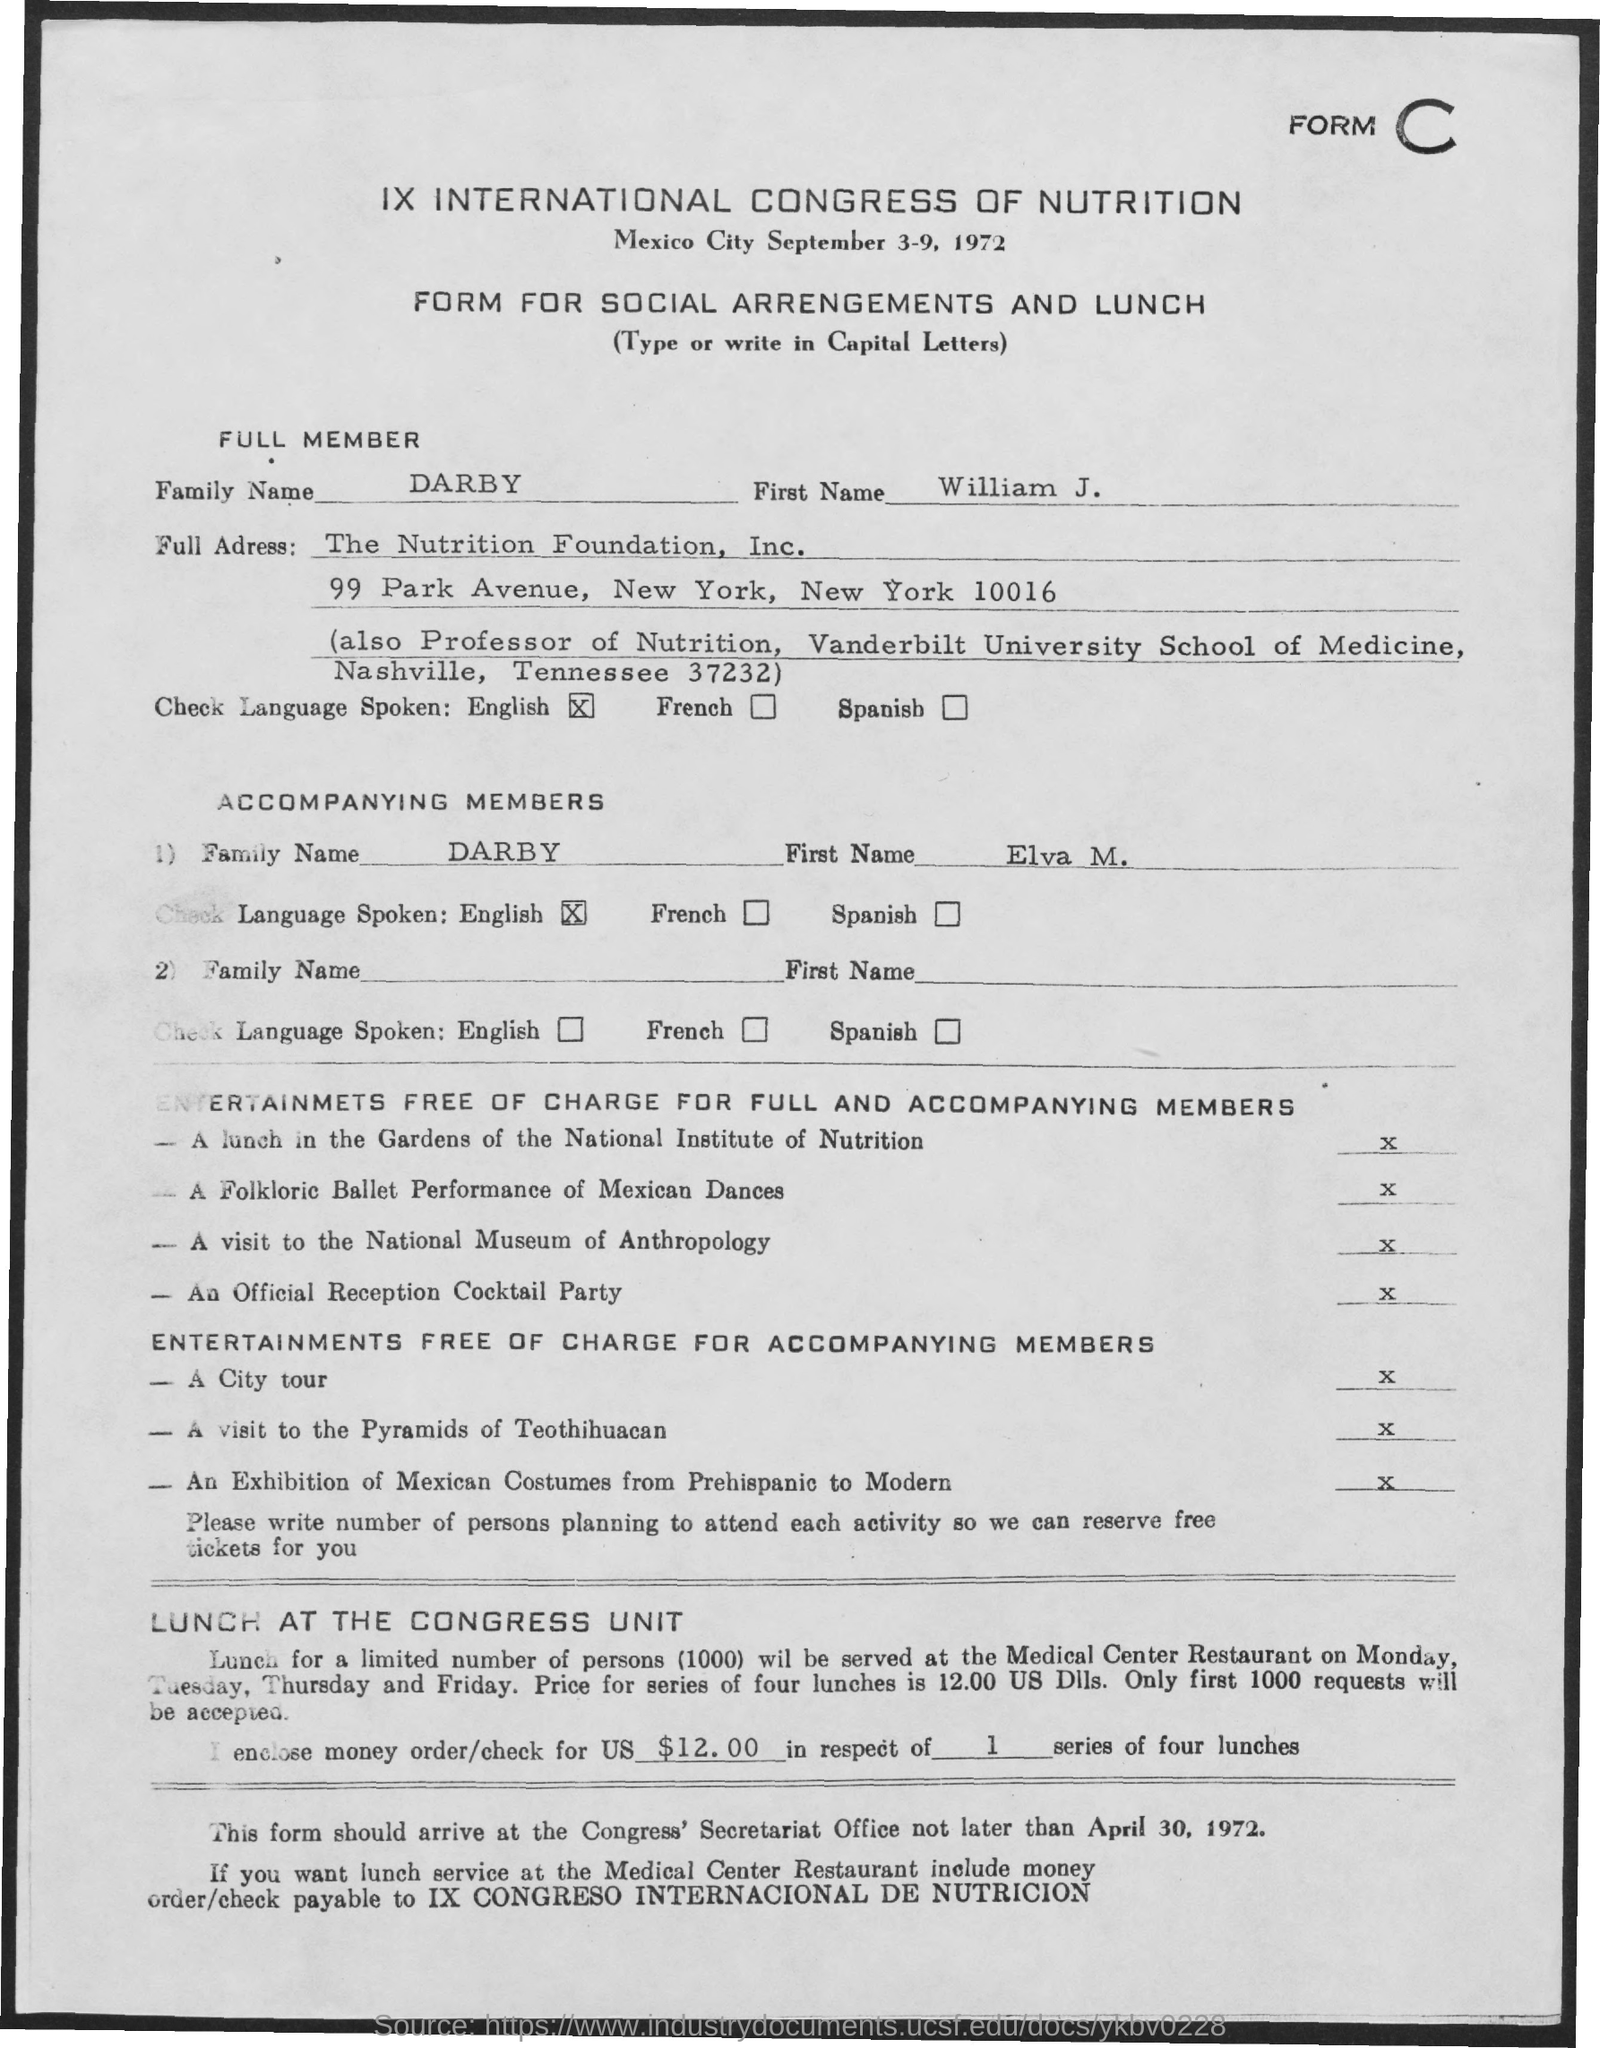First name of the full member?
Keep it short and to the point. WILLIAM J. What type of form is given here?
Your answer should be compact. FORM FOR SOCIAL ARRANGEMENTS AND LUNCH. In which company, William J. Darby works?
Your answer should be compact. THE NUTRITION FOUNDATION, INC. First name of tha accompanying member?
Make the answer very short. ELVA M. Which language is spoken by William J. Darby?
Your answer should be very brief. English. 